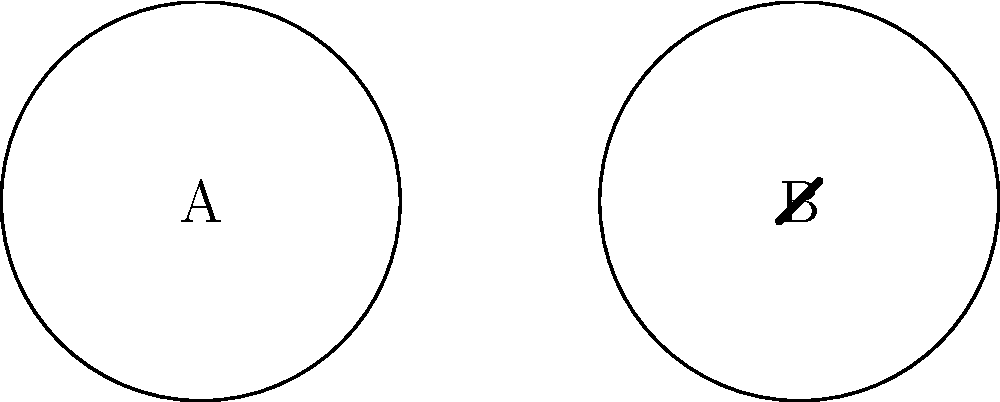Consider the two knots A and B shown in the diagram. Which of these knots has a higher crossing number, and what is the significance of this in knot theory? To answer this question, we need to analyze the crossing number of each knot and understand its importance in knot theory:

1. Crossing number definition: The crossing number of a knot is the minimum number of crossings that occur in any projection of the knot onto a plane.

2. Analyzing knot A:
   - Knot A is a simple closed curve with no crossings.
   - It represents the unknot or trivial knot.
   - Crossing number of A = 0

3. Analyzing knot B:
   - Knot B has one visible crossing in this projection.
   - This is the simplest non-trivial knot, known as the trefoil knot.
   - Crossing number of B = 3 (although only one crossing is visible in this projection, the minimum number of crossings for a trefoil knot is 3)

4. Comparison:
   - Knot B has a higher crossing number (3) compared to knot A (0).

5. Significance in knot theory:
   - The crossing number is an important invariant in knot theory.
   - It helps in classifying and distinguishing different knots.
   - A higher crossing number generally indicates a more complex knot.
   - The crossing number is used in various knot polynomials and other knot invariants.
   - It plays a crucial role in understanding the topology and geometry of knots.

Therefore, knot B (the trefoil knot) has a higher crossing number, which indicates it is a more complex knot than the unknot (A). This classification is fundamental in the study and organization of knots in topology.
Answer: Knot B; higher complexity and non-triviality in knot classification. 